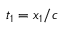<formula> <loc_0><loc_0><loc_500><loc_500>t _ { 1 } = x _ { 1 } / c</formula> 